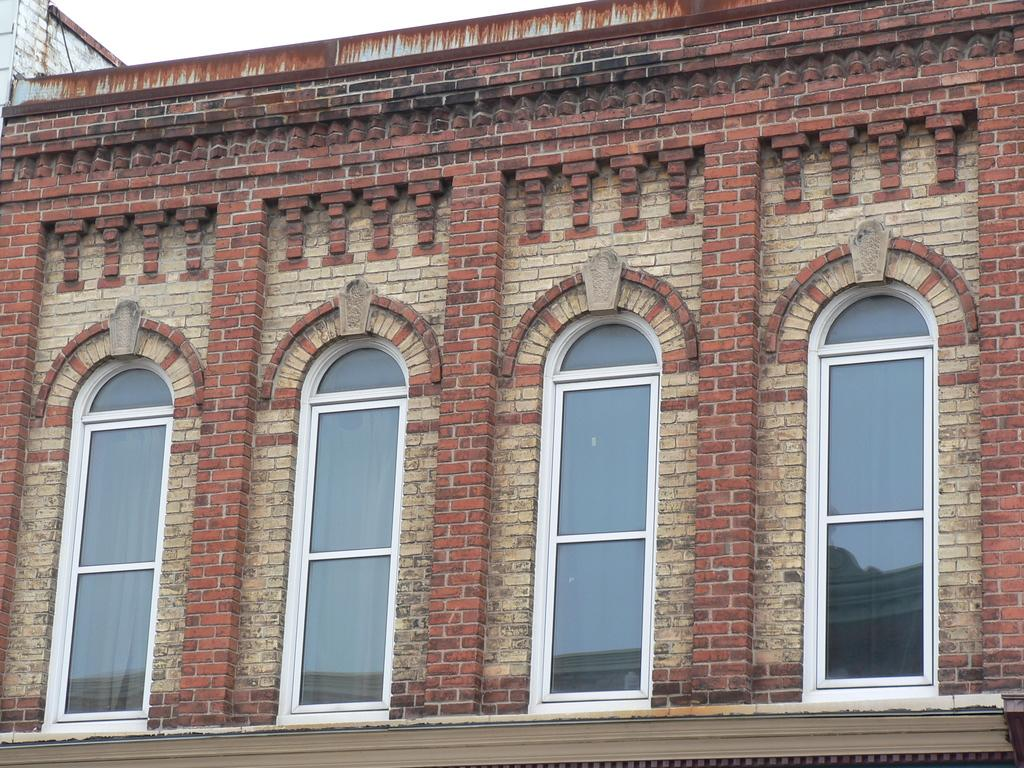What type of structure is present in the image? There is a building in the image. What feature can be seen on the building? The building has windows. What is visible at the top of the image? The sky is visible at the top of the image. Reasoning: Let's think step by following the guidelines to produce the conversation. We start by identifying the main subject in the image, which is the building. Then, we expand the conversation to include other details about the building, such as the presence of windows. Finally, we mention the sky visible at the top of the image. Each question is designed to elicit a specific detail about the image that is known from the provided facts. Absurd Question/Answer: How many crates are stacked on top of the building in the image? There are no crates present in the image; it only features a building with windows and the sky visible at the top. 